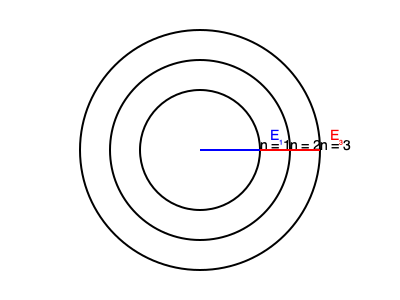In the Bohr model of a hydrogen atom shown above, an electron transitions from the $n=3$ energy level to the $n=1$ energy level. Calculate the energy of the photon emitted during this transition, given that the energy of the $n^{th}$ level is $E_n = -\frac{13.6 \text{ eV}}{n^2}$. Express your answer in electron volts (eV). To solve this problem, we'll follow these steps:

1) Recall the formula for energy levels in the Bohr model:
   $E_n = -\frac{13.6 \text{ eV}}{n^2}$

2) Calculate the energy of the initial state ($n=3$):
   $E_3 = -\frac{13.6 \text{ eV}}{3^2} = -1.51 \text{ eV}$

3) Calculate the energy of the final state ($n=1$):
   $E_1 = -\frac{13.6 \text{ eV}}{1^2} = -13.6 \text{ eV}$

4) The energy of the emitted photon is the difference between these energy levels:
   $E_{photon} = E_{initial} - E_{final} = E_3 - E_1$

5) Substitute the values:
   $E_{photon} = (-1.51 \text{ eV}) - (-13.6 \text{ eV})$

6) Simplify:
   $E_{photon} = 12.09 \text{ eV}$

Therefore, the energy of the emitted photon is 12.09 eV.
Answer: 12.09 eV 